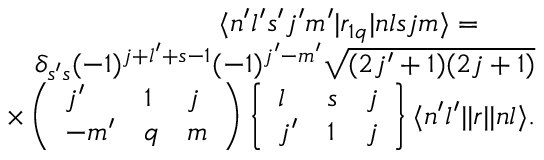<formula> <loc_0><loc_0><loc_500><loc_500>\begin{array} { r } { \langle n ^ { \prime } l ^ { \prime } s ^ { \prime } j ^ { \prime } m ^ { \prime } | r _ { 1 q } | n l s j m \rangle = \quad } \\ { \delta _ { s ^ { \prime } s } ( - 1 ) ^ { j + l ^ { \prime } + s - 1 } ( - 1 ) ^ { j ^ { \prime } - m ^ { \prime } } \sqrt { ( 2 j ^ { \prime } + 1 ) ( 2 j + 1 ) } } \\ { \times \left ( \begin{array} { l l l } { j ^ { \prime } } & { 1 } & { j } \\ { - m ^ { \prime } } & { q } & { m } \end{array} \right ) \left \{ \begin{array} { l l l } { l } & { s } & { j } \\ { j ^ { \prime } } & { 1 } & { j } \end{array} \right \} \langle n ^ { \prime } l ^ { \prime } | | r | | n l \rangle . } \end{array}</formula> 